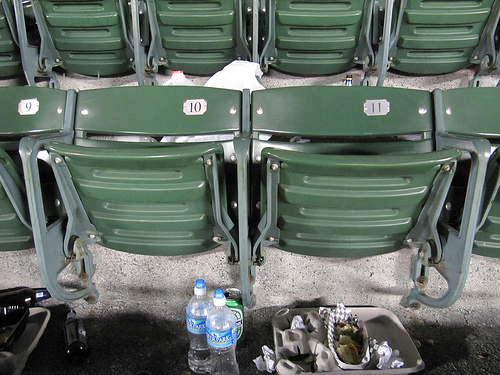<image>
Can you confirm if the bottle is in front of the chair? Yes. The bottle is positioned in front of the chair, appearing closer to the camera viewpoint. 